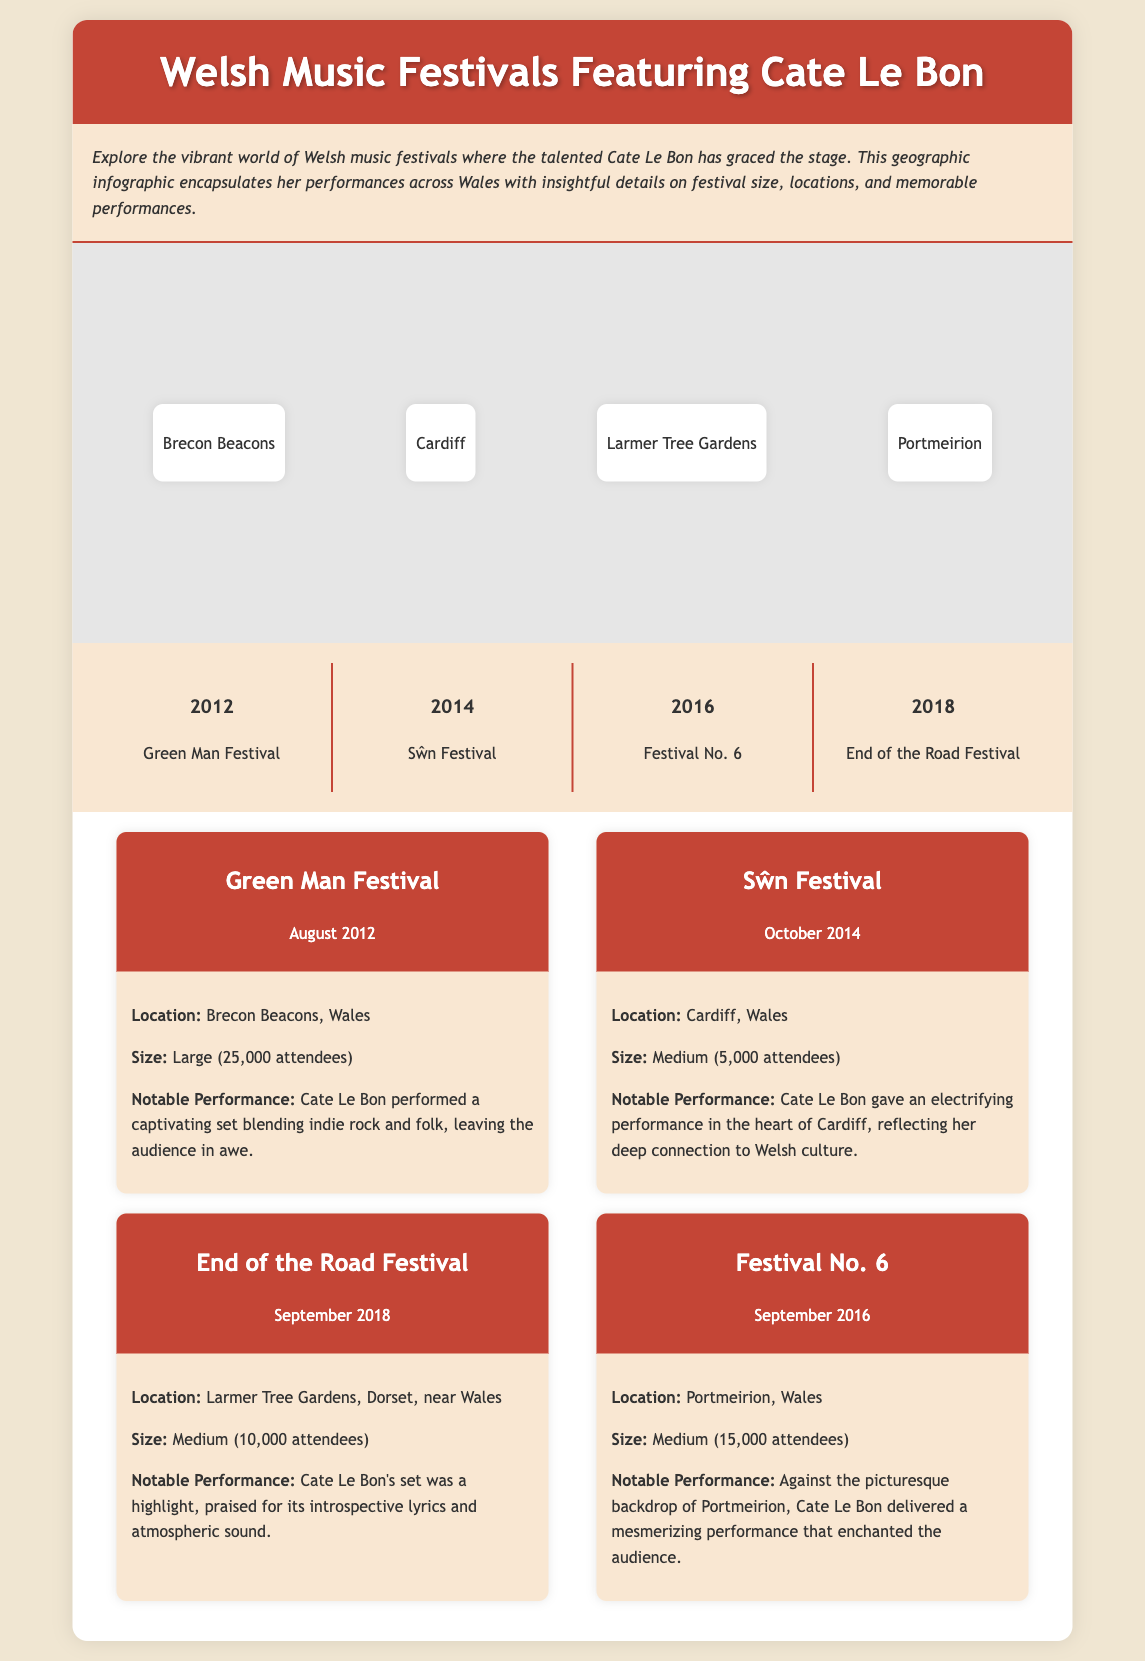What is the title of the infographic? The title of the infographic is explicitly stated in the header section of the document.
Answer: Welsh Music Festivals Featuring Cate Le Bon How many attendees does the Green Man Festival have? The size of the Green Man Festival is described in the festival content section.
Answer: Large (25,000 attendees) In which year did Cate Le Bon perform at the Sŵn Festival? The timeline specifically states the year of Cate Le Bon's performance at the Sŵn Festival.
Answer: 2014 What is the location of the Festival No. 6? The festival content provides the location of Festival No. 6.
Answer: Portmeirion, Wales Which festival had a notable performance praised for introspective lyrics? The notable performances section describes the performances, allowing identification of the relevant festival.
Answer: End of the Road Festival What icons are associated with the Green Man Festival? The festival icons indicate the symbols used for the Green Man Festival in the festival content section.
Answer: Mountain and Guitar How many festivals are listed in total? The festivals section includes a specific number of festivals presented in the infographic.
Answer: Four Which festival took place in September 2018? The timeline includes specific dates for each festival, which will lead to the identification of the festival.
Answer: End of the Road Festival What is the notable performance at the Sŵn Festival about? The notable performance description in the Sŵn Festival content provides insight into the performance's significance.
Answer: Electrifying performance in the heart of Cardiff 